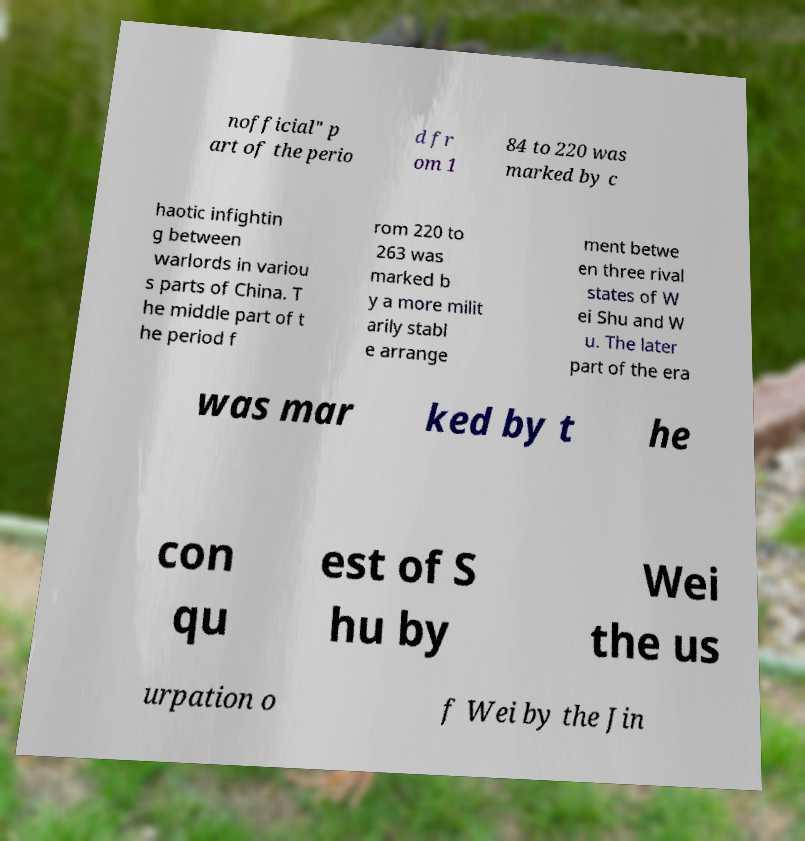Could you extract and type out the text from this image? nofficial" p art of the perio d fr om 1 84 to 220 was marked by c haotic infightin g between warlords in variou s parts of China. T he middle part of t he period f rom 220 to 263 was marked b y a more milit arily stabl e arrange ment betwe en three rival states of W ei Shu and W u. The later part of the era was mar ked by t he con qu est of S hu by Wei the us urpation o f Wei by the Jin 